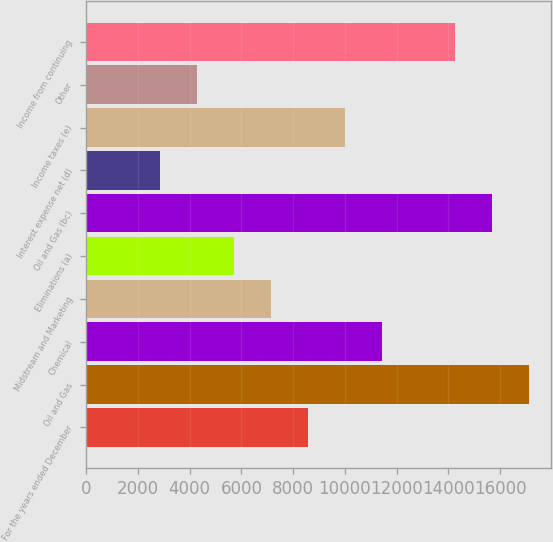<chart> <loc_0><loc_0><loc_500><loc_500><bar_chart><fcel>For the years ended December<fcel>Oil and Gas<fcel>Chemical<fcel>Midstream and Marketing<fcel>Eliminations (a)<fcel>Oil and Gas (bc)<fcel>Interest expense net (d)<fcel>Income taxes (e)<fcel>Other<fcel>Income from continuing<nl><fcel>8567.81<fcel>17130<fcel>11421.9<fcel>7140.77<fcel>5713.73<fcel>15703<fcel>2859.65<fcel>9994.85<fcel>4286.69<fcel>14276<nl></chart> 